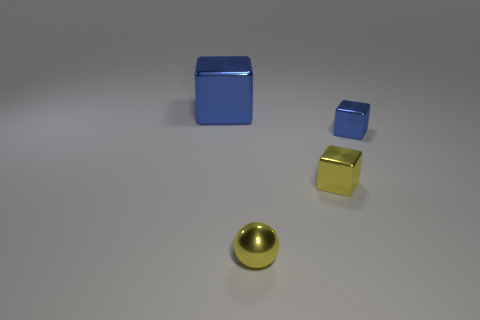Add 2 small red objects. How many objects exist? 6 Subtract all tiny metal blocks. How many blocks are left? 1 Subtract all blue cubes. How many cubes are left? 1 Subtract all cubes. How many objects are left? 1 Add 1 big cubes. How many big cubes are left? 2 Add 1 small blue metallic objects. How many small blue metallic objects exist? 2 Subtract 0 purple cubes. How many objects are left? 4 Subtract all blue blocks. Subtract all blue spheres. How many blocks are left? 1 Subtract all yellow cylinders. How many purple spheres are left? 0 Subtract all yellow balls. Subtract all large brown spheres. How many objects are left? 3 